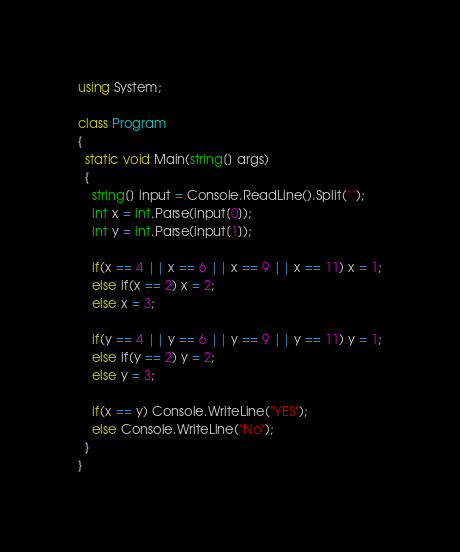Convert code to text. <code><loc_0><loc_0><loc_500><loc_500><_C#_>using System;

class Program
{
  static void Main(string[] args)
  {
    string[] input = Console.ReadLine().Split(' ');
    int x = int.Parse(input[0]);
    int y = int.Parse(input[1]);
    
    if(x == 4 || x == 6 || x == 9 || x == 11) x = 1;
    else if(x == 2) x = 2;
    else x = 3;
    
    if(y == 4 || y == 6 || y == 9 || y == 11) y = 1;
    else if(y == 2) y = 2;
    else y = 3;
    
    if(x == y) Console.WriteLine("YES");
    else Console.WriteLine("No");
  }
}</code> 